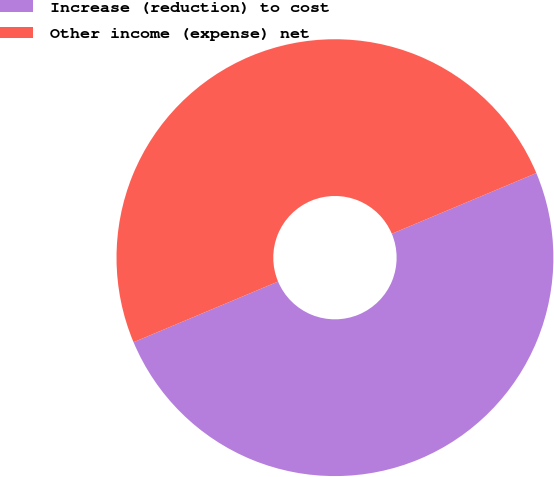<chart> <loc_0><loc_0><loc_500><loc_500><pie_chart><fcel>Increase (reduction) to cost<fcel>Other income (expense) net<nl><fcel>50.0%<fcel>50.0%<nl></chart> 